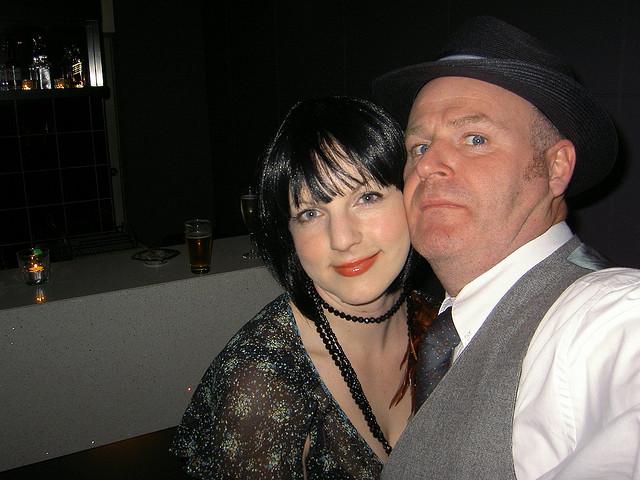Is the ladies necklace onyx?
Quick response, please. Yes. Is this place well lit?
Quick response, please. No. How many people are wearing a tie?
Give a very brief answer. 1. What is on the man's head?
Keep it brief. Hat. 